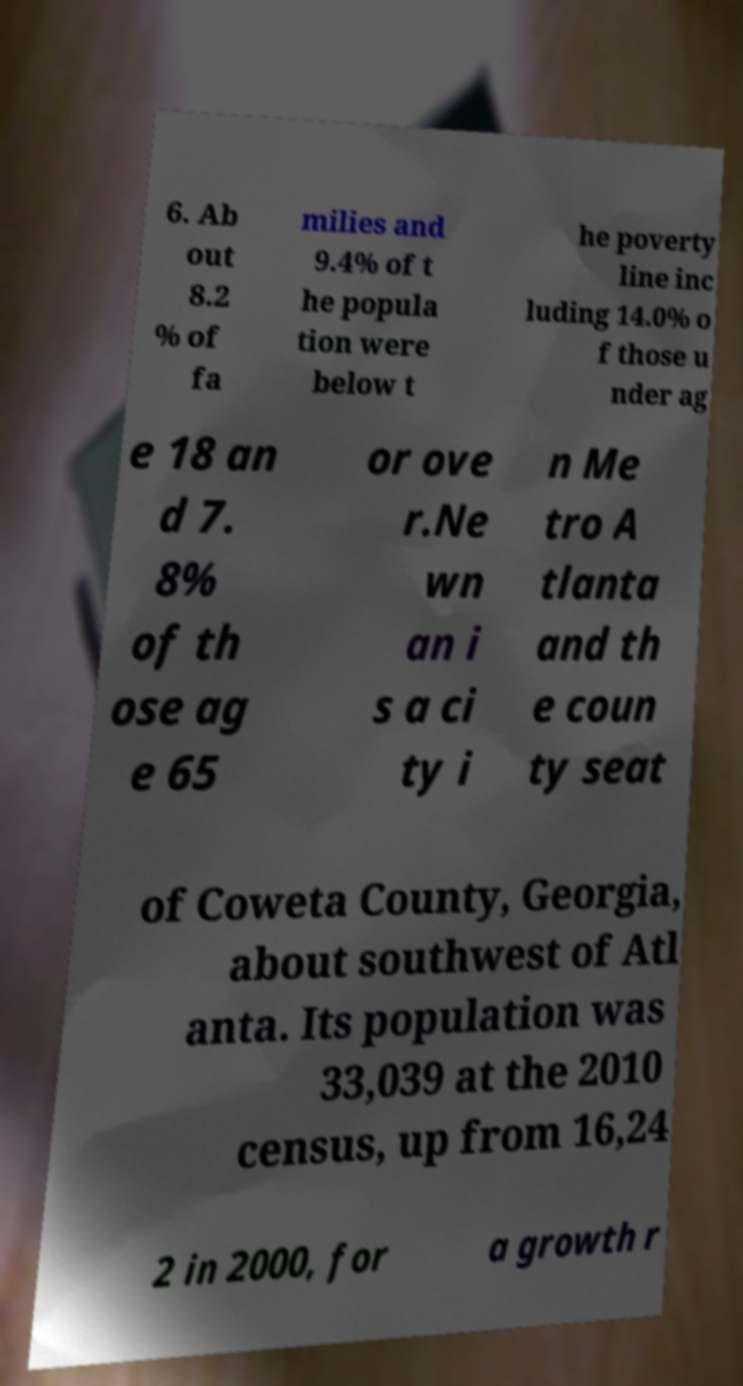Please read and relay the text visible in this image. What does it say? 6. Ab out 8.2 % of fa milies and 9.4% of t he popula tion were below t he poverty line inc luding 14.0% o f those u nder ag e 18 an d 7. 8% of th ose ag e 65 or ove r.Ne wn an i s a ci ty i n Me tro A tlanta and th e coun ty seat of Coweta County, Georgia, about southwest of Atl anta. Its population was 33,039 at the 2010 census, up from 16,24 2 in 2000, for a growth r 